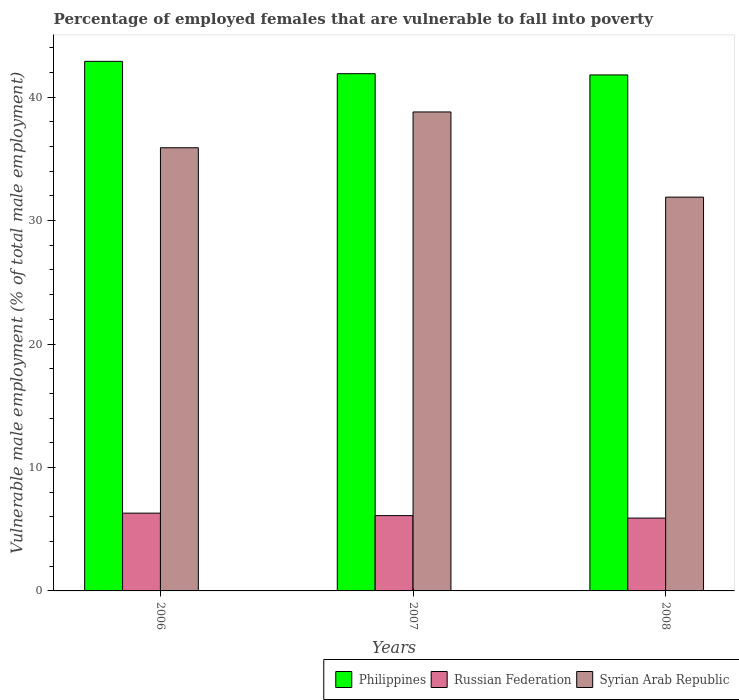How many groups of bars are there?
Your answer should be very brief. 3. How many bars are there on the 3rd tick from the left?
Your answer should be very brief. 3. What is the percentage of employed females who are vulnerable to fall into poverty in Philippines in 2008?
Provide a succinct answer. 41.8. Across all years, what is the maximum percentage of employed females who are vulnerable to fall into poverty in Philippines?
Keep it short and to the point. 42.9. Across all years, what is the minimum percentage of employed females who are vulnerable to fall into poverty in Philippines?
Make the answer very short. 41.8. In which year was the percentage of employed females who are vulnerable to fall into poverty in Russian Federation maximum?
Give a very brief answer. 2006. In which year was the percentage of employed females who are vulnerable to fall into poverty in Philippines minimum?
Keep it short and to the point. 2008. What is the total percentage of employed females who are vulnerable to fall into poverty in Russian Federation in the graph?
Provide a succinct answer. 18.3. What is the difference between the percentage of employed females who are vulnerable to fall into poverty in Philippines in 2006 and that in 2007?
Provide a succinct answer. 1. What is the difference between the percentage of employed females who are vulnerable to fall into poverty in Syrian Arab Republic in 2007 and the percentage of employed females who are vulnerable to fall into poverty in Russian Federation in 2008?
Offer a terse response. 32.9. What is the average percentage of employed females who are vulnerable to fall into poverty in Philippines per year?
Give a very brief answer. 42.2. In the year 2007, what is the difference between the percentage of employed females who are vulnerable to fall into poverty in Philippines and percentage of employed females who are vulnerable to fall into poverty in Syrian Arab Republic?
Make the answer very short. 3.1. In how many years, is the percentage of employed females who are vulnerable to fall into poverty in Syrian Arab Republic greater than 36 %?
Keep it short and to the point. 1. What is the ratio of the percentage of employed females who are vulnerable to fall into poverty in Syrian Arab Republic in 2006 to that in 2007?
Make the answer very short. 0.93. Is the percentage of employed females who are vulnerable to fall into poverty in Philippines in 2007 less than that in 2008?
Keep it short and to the point. No. Is the difference between the percentage of employed females who are vulnerable to fall into poverty in Philippines in 2006 and 2007 greater than the difference between the percentage of employed females who are vulnerable to fall into poverty in Syrian Arab Republic in 2006 and 2007?
Offer a terse response. Yes. What is the difference between the highest and the second highest percentage of employed females who are vulnerable to fall into poverty in Philippines?
Your answer should be compact. 1. What is the difference between the highest and the lowest percentage of employed females who are vulnerable to fall into poverty in Syrian Arab Republic?
Your answer should be compact. 6.9. Is the sum of the percentage of employed females who are vulnerable to fall into poverty in Philippines in 2006 and 2007 greater than the maximum percentage of employed females who are vulnerable to fall into poverty in Russian Federation across all years?
Give a very brief answer. Yes. What does the 3rd bar from the left in 2008 represents?
Ensure brevity in your answer.  Syrian Arab Republic. What does the 2nd bar from the right in 2006 represents?
Your answer should be very brief. Russian Federation. Are the values on the major ticks of Y-axis written in scientific E-notation?
Ensure brevity in your answer.  No. Where does the legend appear in the graph?
Make the answer very short. Bottom right. How many legend labels are there?
Your answer should be very brief. 3. How are the legend labels stacked?
Make the answer very short. Horizontal. What is the title of the graph?
Ensure brevity in your answer.  Percentage of employed females that are vulnerable to fall into poverty. Does "Trinidad and Tobago" appear as one of the legend labels in the graph?
Your response must be concise. No. What is the label or title of the X-axis?
Make the answer very short. Years. What is the label or title of the Y-axis?
Provide a succinct answer. Vulnerable male employment (% of total male employment). What is the Vulnerable male employment (% of total male employment) of Philippines in 2006?
Keep it short and to the point. 42.9. What is the Vulnerable male employment (% of total male employment) in Russian Federation in 2006?
Provide a succinct answer. 6.3. What is the Vulnerable male employment (% of total male employment) of Syrian Arab Republic in 2006?
Offer a terse response. 35.9. What is the Vulnerable male employment (% of total male employment) of Philippines in 2007?
Your answer should be compact. 41.9. What is the Vulnerable male employment (% of total male employment) in Russian Federation in 2007?
Give a very brief answer. 6.1. What is the Vulnerable male employment (% of total male employment) in Syrian Arab Republic in 2007?
Offer a terse response. 38.8. What is the Vulnerable male employment (% of total male employment) of Philippines in 2008?
Offer a very short reply. 41.8. What is the Vulnerable male employment (% of total male employment) of Russian Federation in 2008?
Give a very brief answer. 5.9. What is the Vulnerable male employment (% of total male employment) in Syrian Arab Republic in 2008?
Keep it short and to the point. 31.9. Across all years, what is the maximum Vulnerable male employment (% of total male employment) in Philippines?
Provide a succinct answer. 42.9. Across all years, what is the maximum Vulnerable male employment (% of total male employment) in Russian Federation?
Your answer should be compact. 6.3. Across all years, what is the maximum Vulnerable male employment (% of total male employment) of Syrian Arab Republic?
Give a very brief answer. 38.8. Across all years, what is the minimum Vulnerable male employment (% of total male employment) of Philippines?
Your answer should be compact. 41.8. Across all years, what is the minimum Vulnerable male employment (% of total male employment) in Russian Federation?
Your response must be concise. 5.9. Across all years, what is the minimum Vulnerable male employment (% of total male employment) of Syrian Arab Republic?
Offer a terse response. 31.9. What is the total Vulnerable male employment (% of total male employment) of Philippines in the graph?
Provide a short and direct response. 126.6. What is the total Vulnerable male employment (% of total male employment) in Syrian Arab Republic in the graph?
Your answer should be compact. 106.6. What is the difference between the Vulnerable male employment (% of total male employment) in Russian Federation in 2006 and that in 2008?
Give a very brief answer. 0.4. What is the difference between the Vulnerable male employment (% of total male employment) of Philippines in 2007 and that in 2008?
Provide a succinct answer. 0.1. What is the difference between the Vulnerable male employment (% of total male employment) of Syrian Arab Republic in 2007 and that in 2008?
Offer a terse response. 6.9. What is the difference between the Vulnerable male employment (% of total male employment) of Philippines in 2006 and the Vulnerable male employment (% of total male employment) of Russian Federation in 2007?
Give a very brief answer. 36.8. What is the difference between the Vulnerable male employment (% of total male employment) of Russian Federation in 2006 and the Vulnerable male employment (% of total male employment) of Syrian Arab Republic in 2007?
Give a very brief answer. -32.5. What is the difference between the Vulnerable male employment (% of total male employment) of Philippines in 2006 and the Vulnerable male employment (% of total male employment) of Russian Federation in 2008?
Provide a succinct answer. 37. What is the difference between the Vulnerable male employment (% of total male employment) in Philippines in 2006 and the Vulnerable male employment (% of total male employment) in Syrian Arab Republic in 2008?
Ensure brevity in your answer.  11. What is the difference between the Vulnerable male employment (% of total male employment) in Russian Federation in 2006 and the Vulnerable male employment (% of total male employment) in Syrian Arab Republic in 2008?
Offer a terse response. -25.6. What is the difference between the Vulnerable male employment (% of total male employment) of Russian Federation in 2007 and the Vulnerable male employment (% of total male employment) of Syrian Arab Republic in 2008?
Ensure brevity in your answer.  -25.8. What is the average Vulnerable male employment (% of total male employment) in Philippines per year?
Keep it short and to the point. 42.2. What is the average Vulnerable male employment (% of total male employment) of Russian Federation per year?
Your response must be concise. 6.1. What is the average Vulnerable male employment (% of total male employment) in Syrian Arab Republic per year?
Provide a succinct answer. 35.53. In the year 2006, what is the difference between the Vulnerable male employment (% of total male employment) in Philippines and Vulnerable male employment (% of total male employment) in Russian Federation?
Keep it short and to the point. 36.6. In the year 2006, what is the difference between the Vulnerable male employment (% of total male employment) in Philippines and Vulnerable male employment (% of total male employment) in Syrian Arab Republic?
Make the answer very short. 7. In the year 2006, what is the difference between the Vulnerable male employment (% of total male employment) of Russian Federation and Vulnerable male employment (% of total male employment) of Syrian Arab Republic?
Provide a short and direct response. -29.6. In the year 2007, what is the difference between the Vulnerable male employment (% of total male employment) of Philippines and Vulnerable male employment (% of total male employment) of Russian Federation?
Offer a terse response. 35.8. In the year 2007, what is the difference between the Vulnerable male employment (% of total male employment) in Philippines and Vulnerable male employment (% of total male employment) in Syrian Arab Republic?
Provide a short and direct response. 3.1. In the year 2007, what is the difference between the Vulnerable male employment (% of total male employment) of Russian Federation and Vulnerable male employment (% of total male employment) of Syrian Arab Republic?
Your answer should be compact. -32.7. In the year 2008, what is the difference between the Vulnerable male employment (% of total male employment) in Philippines and Vulnerable male employment (% of total male employment) in Russian Federation?
Keep it short and to the point. 35.9. In the year 2008, what is the difference between the Vulnerable male employment (% of total male employment) in Philippines and Vulnerable male employment (% of total male employment) in Syrian Arab Republic?
Your response must be concise. 9.9. In the year 2008, what is the difference between the Vulnerable male employment (% of total male employment) of Russian Federation and Vulnerable male employment (% of total male employment) of Syrian Arab Republic?
Offer a very short reply. -26. What is the ratio of the Vulnerable male employment (% of total male employment) of Philippines in 2006 to that in 2007?
Ensure brevity in your answer.  1.02. What is the ratio of the Vulnerable male employment (% of total male employment) of Russian Federation in 2006 to that in 2007?
Give a very brief answer. 1.03. What is the ratio of the Vulnerable male employment (% of total male employment) of Syrian Arab Republic in 2006 to that in 2007?
Offer a very short reply. 0.93. What is the ratio of the Vulnerable male employment (% of total male employment) in Philippines in 2006 to that in 2008?
Give a very brief answer. 1.03. What is the ratio of the Vulnerable male employment (% of total male employment) in Russian Federation in 2006 to that in 2008?
Provide a short and direct response. 1.07. What is the ratio of the Vulnerable male employment (% of total male employment) in Syrian Arab Republic in 2006 to that in 2008?
Keep it short and to the point. 1.13. What is the ratio of the Vulnerable male employment (% of total male employment) of Russian Federation in 2007 to that in 2008?
Give a very brief answer. 1.03. What is the ratio of the Vulnerable male employment (% of total male employment) in Syrian Arab Republic in 2007 to that in 2008?
Give a very brief answer. 1.22. What is the difference between the highest and the lowest Vulnerable male employment (% of total male employment) in Philippines?
Offer a very short reply. 1.1. 